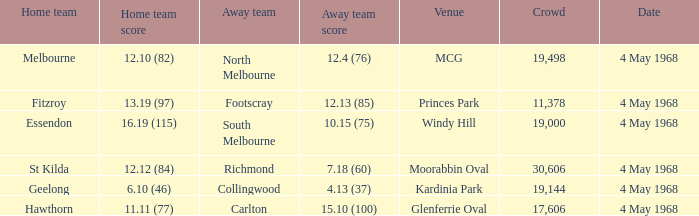What home team played at MCG? North Melbourne. 